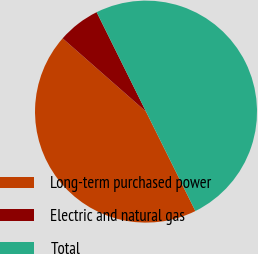Convert chart to OTSL. <chart><loc_0><loc_0><loc_500><loc_500><pie_chart><fcel>Long-term purchased power<fcel>Electric and natural gas<fcel>Total<nl><fcel>43.81%<fcel>6.19%<fcel>50.0%<nl></chart> 